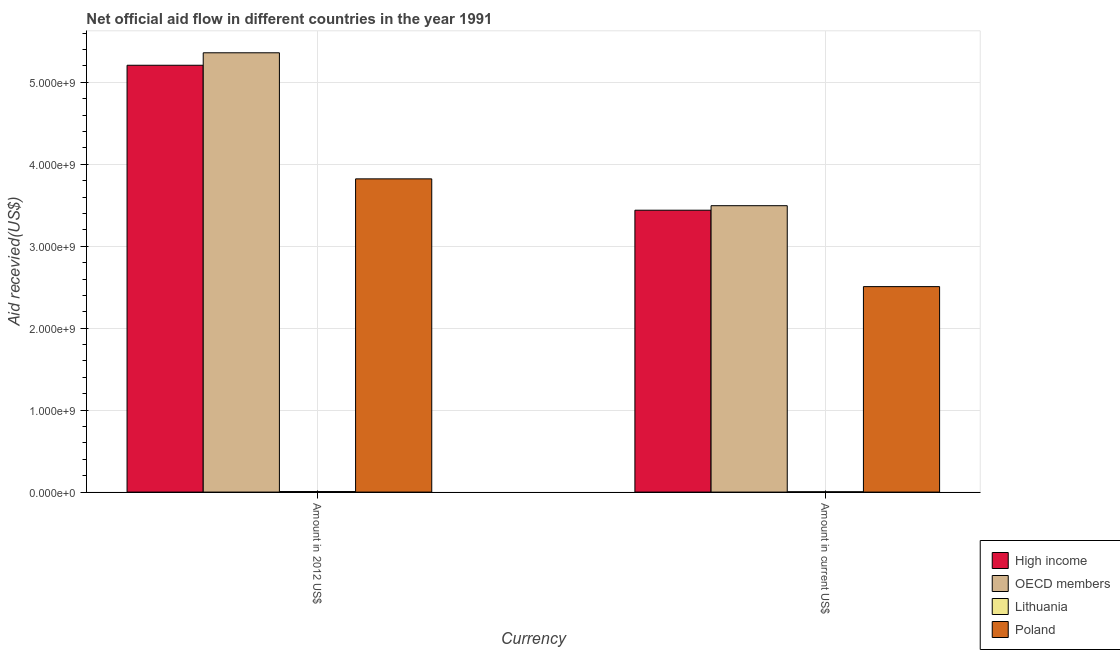Are the number of bars on each tick of the X-axis equal?
Make the answer very short. Yes. How many bars are there on the 2nd tick from the left?
Ensure brevity in your answer.  4. What is the label of the 2nd group of bars from the left?
Your answer should be very brief. Amount in current US$. What is the amount of aid received(expressed in 2012 us$) in Poland?
Ensure brevity in your answer.  3.82e+09. Across all countries, what is the maximum amount of aid received(expressed in 2012 us$)?
Offer a terse response. 5.36e+09. Across all countries, what is the minimum amount of aid received(expressed in 2012 us$)?
Keep it short and to the point. 6.51e+06. In which country was the amount of aid received(expressed in us$) minimum?
Offer a terse response. Lithuania. What is the total amount of aid received(expressed in 2012 us$) in the graph?
Your answer should be very brief. 1.44e+1. What is the difference between the amount of aid received(expressed in 2012 us$) in Poland and that in High income?
Your answer should be compact. -1.39e+09. What is the difference between the amount of aid received(expressed in 2012 us$) in Poland and the amount of aid received(expressed in us$) in High income?
Offer a terse response. 3.83e+08. What is the average amount of aid received(expressed in us$) per country?
Offer a very short reply. 2.36e+09. What is the difference between the amount of aid received(expressed in 2012 us$) and amount of aid received(expressed in us$) in Lithuania?
Provide a short and direct response. 2.55e+06. What is the ratio of the amount of aid received(expressed in 2012 us$) in OECD members to that in High income?
Your answer should be compact. 1.03. In how many countries, is the amount of aid received(expressed in 2012 us$) greater than the average amount of aid received(expressed in 2012 us$) taken over all countries?
Offer a terse response. 3. What does the 2nd bar from the left in Amount in 2012 US$ represents?
Your response must be concise. OECD members. What does the 1st bar from the right in Amount in 2012 US$ represents?
Your answer should be very brief. Poland. How many bars are there?
Offer a terse response. 8. What is the difference between two consecutive major ticks on the Y-axis?
Your answer should be compact. 1.00e+09. Are the values on the major ticks of Y-axis written in scientific E-notation?
Offer a very short reply. Yes. Does the graph contain any zero values?
Your response must be concise. No. Does the graph contain grids?
Ensure brevity in your answer.  Yes. Where does the legend appear in the graph?
Provide a succinct answer. Bottom right. How are the legend labels stacked?
Your answer should be compact. Vertical. What is the title of the graph?
Offer a terse response. Net official aid flow in different countries in the year 1991. What is the label or title of the X-axis?
Offer a terse response. Currency. What is the label or title of the Y-axis?
Your answer should be very brief. Aid recevied(US$). What is the Aid recevied(US$) of High income in Amount in 2012 US$?
Your answer should be very brief. 5.21e+09. What is the Aid recevied(US$) in OECD members in Amount in 2012 US$?
Provide a short and direct response. 5.36e+09. What is the Aid recevied(US$) in Lithuania in Amount in 2012 US$?
Offer a terse response. 6.51e+06. What is the Aid recevied(US$) in Poland in Amount in 2012 US$?
Offer a very short reply. 3.82e+09. What is the Aid recevied(US$) of High income in Amount in current US$?
Keep it short and to the point. 3.44e+09. What is the Aid recevied(US$) of OECD members in Amount in current US$?
Provide a succinct answer. 3.49e+09. What is the Aid recevied(US$) in Lithuania in Amount in current US$?
Your answer should be very brief. 3.96e+06. What is the Aid recevied(US$) of Poland in Amount in current US$?
Offer a terse response. 2.51e+09. Across all Currency, what is the maximum Aid recevied(US$) in High income?
Ensure brevity in your answer.  5.21e+09. Across all Currency, what is the maximum Aid recevied(US$) of OECD members?
Offer a terse response. 5.36e+09. Across all Currency, what is the maximum Aid recevied(US$) in Lithuania?
Ensure brevity in your answer.  6.51e+06. Across all Currency, what is the maximum Aid recevied(US$) of Poland?
Give a very brief answer. 3.82e+09. Across all Currency, what is the minimum Aid recevied(US$) of High income?
Ensure brevity in your answer.  3.44e+09. Across all Currency, what is the minimum Aid recevied(US$) of OECD members?
Ensure brevity in your answer.  3.49e+09. Across all Currency, what is the minimum Aid recevied(US$) of Lithuania?
Your answer should be compact. 3.96e+06. Across all Currency, what is the minimum Aid recevied(US$) of Poland?
Provide a succinct answer. 2.51e+09. What is the total Aid recevied(US$) of High income in the graph?
Your answer should be very brief. 8.65e+09. What is the total Aid recevied(US$) in OECD members in the graph?
Your answer should be very brief. 8.85e+09. What is the total Aid recevied(US$) in Lithuania in the graph?
Keep it short and to the point. 1.05e+07. What is the total Aid recevied(US$) in Poland in the graph?
Offer a very short reply. 6.33e+09. What is the difference between the Aid recevied(US$) in High income in Amount in 2012 US$ and that in Amount in current US$?
Keep it short and to the point. 1.77e+09. What is the difference between the Aid recevied(US$) of OECD members in Amount in 2012 US$ and that in Amount in current US$?
Provide a succinct answer. 1.87e+09. What is the difference between the Aid recevied(US$) of Lithuania in Amount in 2012 US$ and that in Amount in current US$?
Your response must be concise. 2.55e+06. What is the difference between the Aid recevied(US$) in Poland in Amount in 2012 US$ and that in Amount in current US$?
Provide a succinct answer. 1.31e+09. What is the difference between the Aid recevied(US$) in High income in Amount in 2012 US$ and the Aid recevied(US$) in OECD members in Amount in current US$?
Provide a short and direct response. 1.71e+09. What is the difference between the Aid recevied(US$) in High income in Amount in 2012 US$ and the Aid recevied(US$) in Lithuania in Amount in current US$?
Make the answer very short. 5.20e+09. What is the difference between the Aid recevied(US$) in High income in Amount in 2012 US$ and the Aid recevied(US$) in Poland in Amount in current US$?
Keep it short and to the point. 2.70e+09. What is the difference between the Aid recevied(US$) in OECD members in Amount in 2012 US$ and the Aid recevied(US$) in Lithuania in Amount in current US$?
Make the answer very short. 5.36e+09. What is the difference between the Aid recevied(US$) in OECD members in Amount in 2012 US$ and the Aid recevied(US$) in Poland in Amount in current US$?
Provide a succinct answer. 2.85e+09. What is the difference between the Aid recevied(US$) of Lithuania in Amount in 2012 US$ and the Aid recevied(US$) of Poland in Amount in current US$?
Provide a short and direct response. -2.50e+09. What is the average Aid recevied(US$) of High income per Currency?
Provide a succinct answer. 4.32e+09. What is the average Aid recevied(US$) of OECD members per Currency?
Your answer should be compact. 4.43e+09. What is the average Aid recevied(US$) in Lithuania per Currency?
Offer a very short reply. 5.24e+06. What is the average Aid recevied(US$) in Poland per Currency?
Make the answer very short. 3.16e+09. What is the difference between the Aid recevied(US$) in High income and Aid recevied(US$) in OECD members in Amount in 2012 US$?
Offer a very short reply. -1.52e+08. What is the difference between the Aid recevied(US$) of High income and Aid recevied(US$) of Lithuania in Amount in 2012 US$?
Provide a short and direct response. 5.20e+09. What is the difference between the Aid recevied(US$) of High income and Aid recevied(US$) of Poland in Amount in 2012 US$?
Ensure brevity in your answer.  1.39e+09. What is the difference between the Aid recevied(US$) in OECD members and Aid recevied(US$) in Lithuania in Amount in 2012 US$?
Provide a short and direct response. 5.35e+09. What is the difference between the Aid recevied(US$) in OECD members and Aid recevied(US$) in Poland in Amount in 2012 US$?
Your response must be concise. 1.54e+09. What is the difference between the Aid recevied(US$) in Lithuania and Aid recevied(US$) in Poland in Amount in 2012 US$?
Your answer should be very brief. -3.82e+09. What is the difference between the Aid recevied(US$) of High income and Aid recevied(US$) of OECD members in Amount in current US$?
Provide a short and direct response. -5.51e+07. What is the difference between the Aid recevied(US$) of High income and Aid recevied(US$) of Lithuania in Amount in current US$?
Keep it short and to the point. 3.44e+09. What is the difference between the Aid recevied(US$) in High income and Aid recevied(US$) in Poland in Amount in current US$?
Your answer should be very brief. 9.32e+08. What is the difference between the Aid recevied(US$) of OECD members and Aid recevied(US$) of Lithuania in Amount in current US$?
Offer a terse response. 3.49e+09. What is the difference between the Aid recevied(US$) of OECD members and Aid recevied(US$) of Poland in Amount in current US$?
Your answer should be compact. 9.87e+08. What is the difference between the Aid recevied(US$) of Lithuania and Aid recevied(US$) of Poland in Amount in current US$?
Offer a very short reply. -2.50e+09. What is the ratio of the Aid recevied(US$) of High income in Amount in 2012 US$ to that in Amount in current US$?
Keep it short and to the point. 1.51. What is the ratio of the Aid recevied(US$) of OECD members in Amount in 2012 US$ to that in Amount in current US$?
Ensure brevity in your answer.  1.53. What is the ratio of the Aid recevied(US$) in Lithuania in Amount in 2012 US$ to that in Amount in current US$?
Ensure brevity in your answer.  1.64. What is the ratio of the Aid recevied(US$) of Poland in Amount in 2012 US$ to that in Amount in current US$?
Keep it short and to the point. 1.52. What is the difference between the highest and the second highest Aid recevied(US$) in High income?
Make the answer very short. 1.77e+09. What is the difference between the highest and the second highest Aid recevied(US$) of OECD members?
Ensure brevity in your answer.  1.87e+09. What is the difference between the highest and the second highest Aid recevied(US$) in Lithuania?
Offer a terse response. 2.55e+06. What is the difference between the highest and the second highest Aid recevied(US$) in Poland?
Give a very brief answer. 1.31e+09. What is the difference between the highest and the lowest Aid recevied(US$) of High income?
Your answer should be very brief. 1.77e+09. What is the difference between the highest and the lowest Aid recevied(US$) in OECD members?
Your response must be concise. 1.87e+09. What is the difference between the highest and the lowest Aid recevied(US$) of Lithuania?
Provide a short and direct response. 2.55e+06. What is the difference between the highest and the lowest Aid recevied(US$) of Poland?
Ensure brevity in your answer.  1.31e+09. 